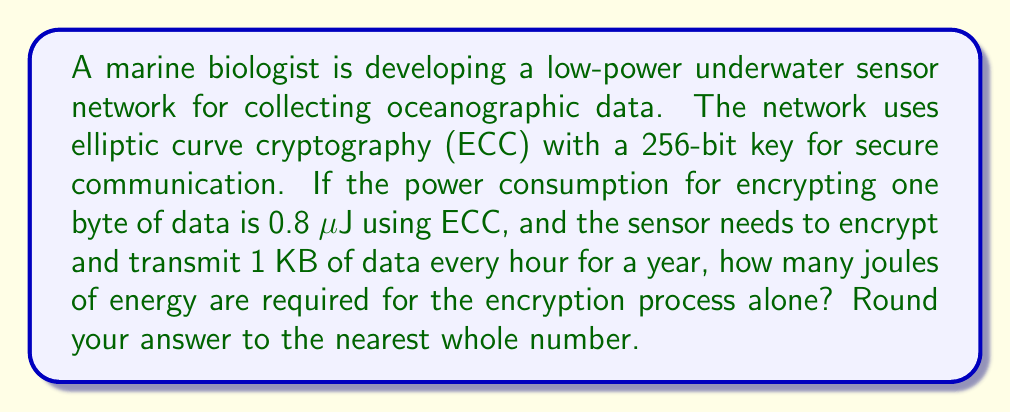Help me with this question. Let's break this problem down into steps:

1. Convert 1 KB to bytes:
   $1 \text{ KB} = 1024 \text{ bytes}$

2. Calculate the energy required to encrypt 1 KB:
   $1024 \text{ bytes} \times 0.8 \text{ μJ/byte} = 819.2 \text{ μJ}$

3. Convert μJ to J:
   $819.2 \text{ μJ} = 819.2 \times 10^{-6} \text{ J} = 0.0008192 \text{ J}$

4. Calculate the number of transmissions in a year:
   $365 \text{ days} \times 24 \text{ hours/day} = 8760 \text{ transmissions}$

5. Calculate the total energy required for a year:
   $0.0008192 \text{ J/transmission} \times 8760 \text{ transmissions} = 7.176192 \text{ J}$

6. Round to the nearest whole number:
   $7.176192 \text{ J} \approx 7 \text{ J}$

Therefore, the energy required for the encryption process alone is approximately 7 joules.
Answer: 7 J 